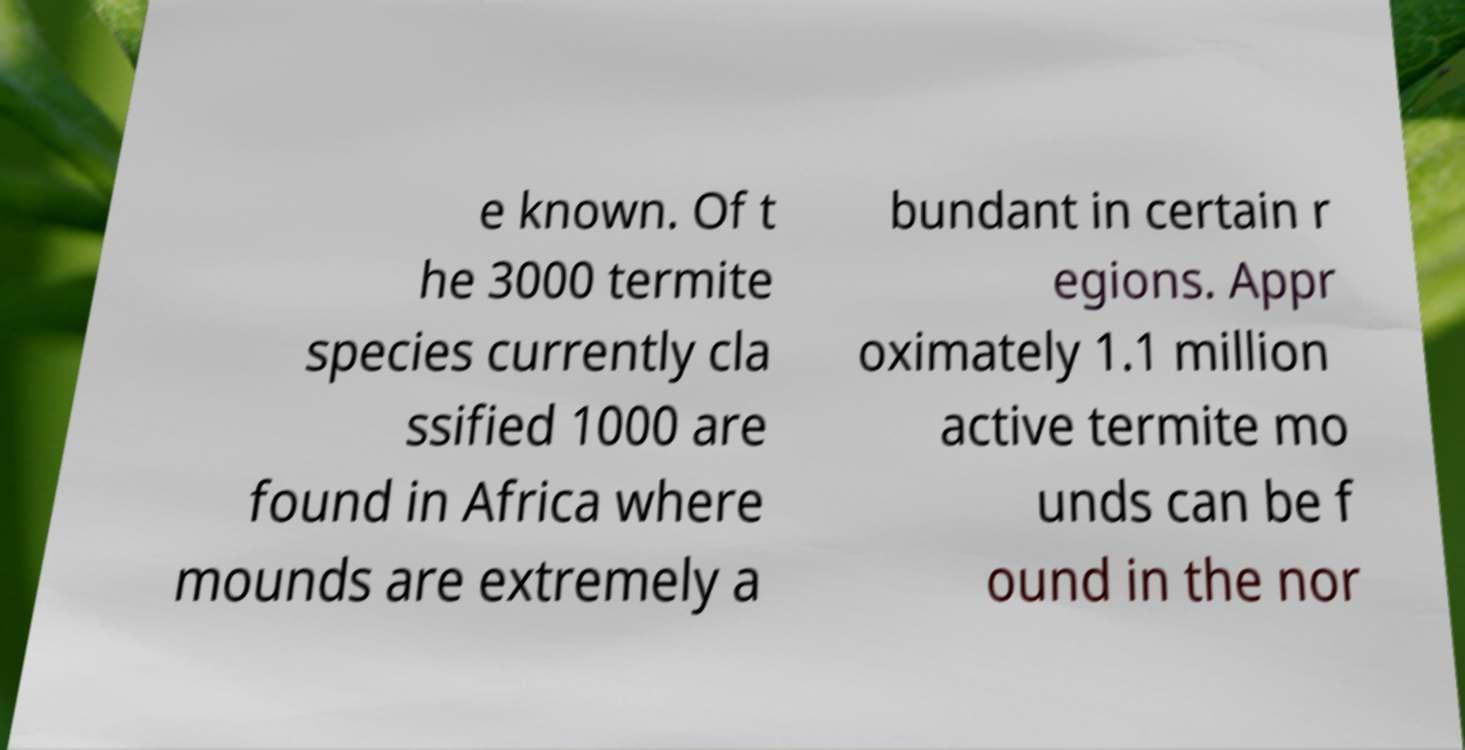Please read and relay the text visible in this image. What does it say? e known. Of t he 3000 termite species currently cla ssified 1000 are found in Africa where mounds are extremely a bundant in certain r egions. Appr oximately 1.1 million active termite mo unds can be f ound in the nor 